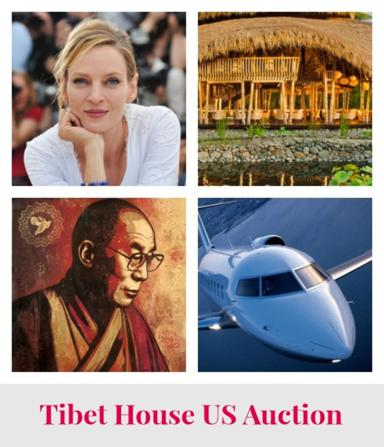Why might the painting of a monk be significant in this collage? The painting of the monk is significant as it likely represents the spiritual and cultural heritage that Tibet House aims to preserve and celebrate. Such imagery underscores the deep cultural and religious roots that the auction supports. 